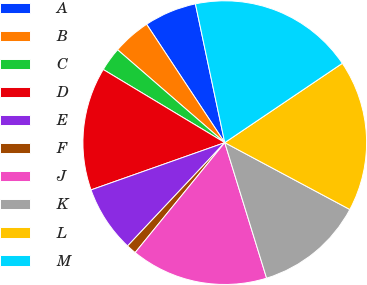Convert chart. <chart><loc_0><loc_0><loc_500><loc_500><pie_chart><fcel>A<fcel>B<fcel>C<fcel>D<fcel>E<fcel>F<fcel>J<fcel>K<fcel>L<fcel>M<nl><fcel>5.97%<fcel>4.35%<fcel>2.74%<fcel>14.03%<fcel>7.58%<fcel>1.13%<fcel>15.65%<fcel>12.42%<fcel>17.26%<fcel>18.87%<nl></chart> 